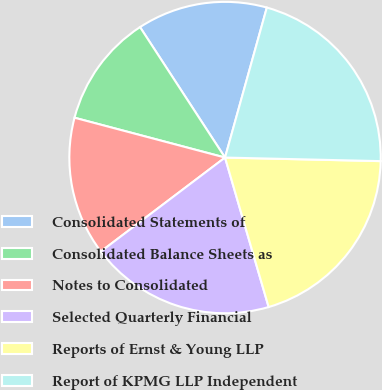Convert chart. <chart><loc_0><loc_0><loc_500><loc_500><pie_chart><fcel>Consolidated Statements of<fcel>Consolidated Balance Sheets as<fcel>Notes to Consolidated<fcel>Selected Quarterly Financial<fcel>Reports of Ernst & Young LLP<fcel>Report of KPMG LLP Independent<nl><fcel>13.52%<fcel>11.69%<fcel>14.43%<fcel>19.21%<fcel>20.12%<fcel>21.04%<nl></chart> 